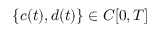Convert formula to latex. <formula><loc_0><loc_0><loc_500><loc_500>\{ c ( t ) , d ( t ) \} \in C [ 0 , T ]</formula> 